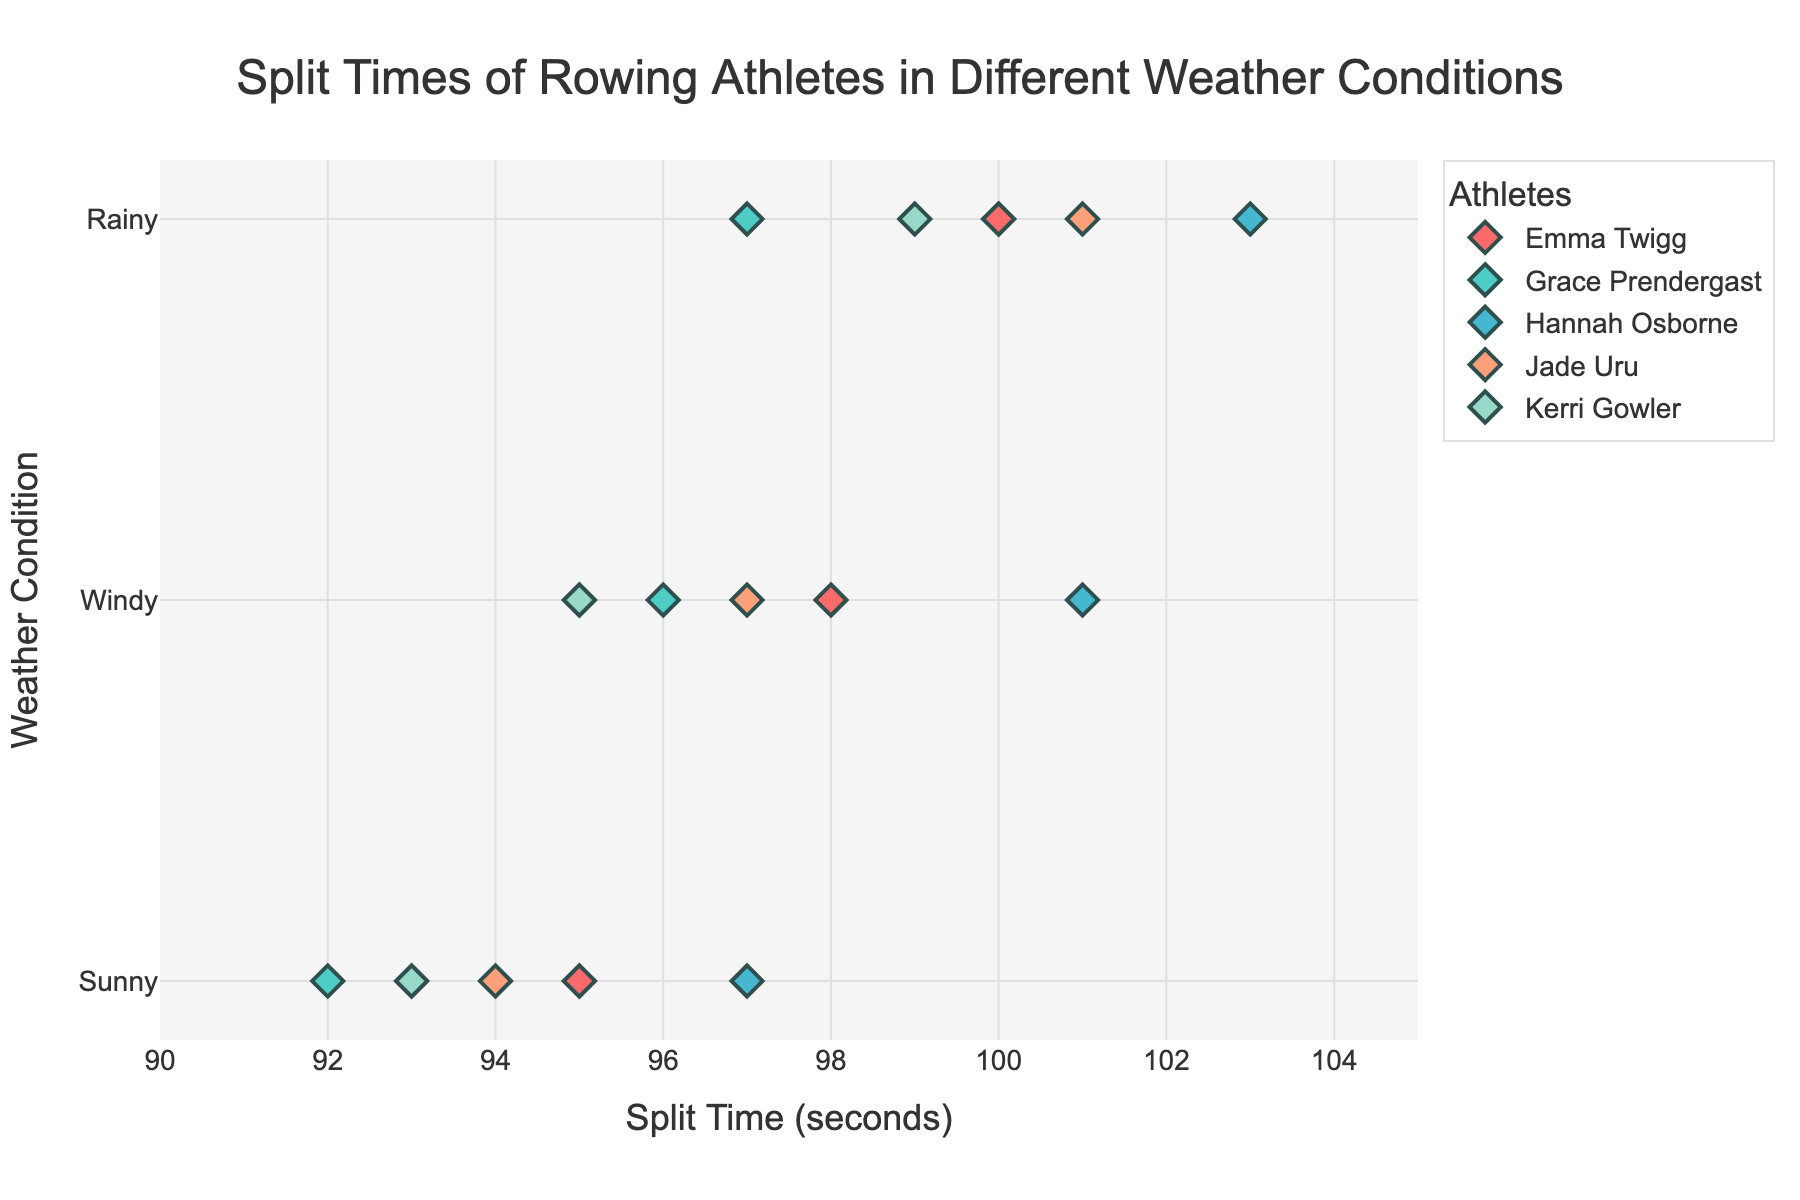What is the title of the figure? The title is typically displayed at the top of a figure and provides a brief description of what the figure is about.
Answer: Split Times of Rowing Athletes in Different Weather Conditions Which weather condition generally shows the fastest split times? By looking at the position of the markers on the x-axis, the fastest split times are represented by values further to the left. Compare the split times under different weather conditions.
Answer: Sunny Which athlete has the best (i.e., lowest) split time in Sunny conditions? Identify the marker corresponding to the sunny condition and the lowest split time value for each athlete, then determine the lowest among them.
Answer: Grace Prendergast What is the biggest difference in split times for any single athlete between the Sunny and Rainy conditions? For each athlete, compute the absolute difference between their split times in Sunny and Rainy conditions, and find the maximum difference.
Answer: Hannah Osborne (103 - 97 = 6 seconds) Compare the split times of Hannah Osborne and Jade Uru in Windy conditions. Who has the faster time? Locate the markers for Hannah Osborne and Jade Uru under Windy conditions and compare their x-axis positions to determine the faster time.
Answer: Hannah Osborne (101 seconds) How many athletes have a split time of 100 seconds or more in Rainy conditions? Count the markers under Rainy conditions that fall on or to the right of the 100-second mark on the x-axis.
Answer: Three (Emma Twigg, Hannah Osborne, Jade Uru) Is there any athlete whose split time consistently decreases from Rainy to Windy to Sunny conditions? Check each athlete's split times across the three weather conditions for a consistent decrease from Rainy to Windy to Sunny.
Answer: Grace Prendergast What is the range of split times for Kerri Gowler across all weather conditions? Identify Kerri Gowler’s split times under all three conditions and calculate the range (maximum value minus minimum value).
Answer: 99 - 93 = 6 seconds Which athlete has the smallest difference in split times between any two weather conditions? For each athlete, calculate the pairwise differences between their split times in the different weather conditions and find the smallest of these differences.
Answer: Grace Prendergast (Windy 96 - Rainy 97 = 1 second) What is the average split time for all athletes in Sunny conditions? Add up the split times for all athletes in Sunny conditions and divide by the number of athletes.
Answer: (95 + 97 + 92 + 93 + 94) / 5 = 94.2 seconds 